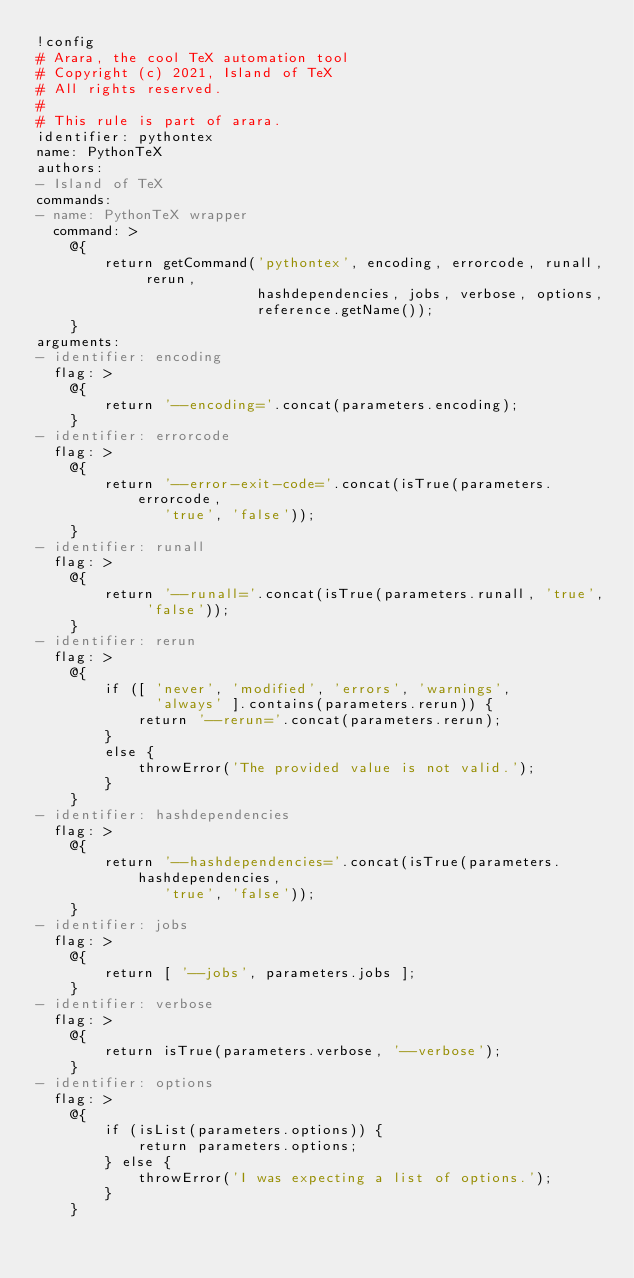Convert code to text. <code><loc_0><loc_0><loc_500><loc_500><_YAML_>!config
# Arara, the cool TeX automation tool
# Copyright (c) 2021, Island of TeX
# All rights reserved.
#
# This rule is part of arara.
identifier: pythontex
name: PythonTeX
authors:
- Island of TeX
commands:
- name: PythonTeX wrapper
  command: >
    @{
        return getCommand('pythontex', encoding, errorcode, runall, rerun,
                          hashdependencies, jobs, verbose, options,
                          reference.getName());
    }
arguments:
- identifier: encoding
  flag: >
    @{
        return '--encoding='.concat(parameters.encoding);
    }
- identifier: errorcode
  flag: >
    @{
        return '--error-exit-code='.concat(isTrue(parameters.errorcode,
               'true', 'false'));
    }
- identifier: runall
  flag: >
    @{
        return '--runall='.concat(isTrue(parameters.runall, 'true', 'false'));
    }
- identifier: rerun
  flag: >
    @{
        if ([ 'never', 'modified', 'errors', 'warnings',
              'always' ].contains(parameters.rerun)) {
            return '--rerun='.concat(parameters.rerun);
        }
        else {
            throwError('The provided value is not valid.');
        }
    }
- identifier: hashdependencies
  flag: >
    @{
        return '--hashdependencies='.concat(isTrue(parameters.hashdependencies,
               'true', 'false'));
    }
- identifier: jobs
  flag: >
    @{
        return [ '--jobs', parameters.jobs ];
    }
- identifier: verbose
  flag: >
    @{
        return isTrue(parameters.verbose, '--verbose');
    }
- identifier: options
  flag: >
    @{
        if (isList(parameters.options)) {
            return parameters.options;
        } else {
            throwError('I was expecting a list of options.');
        }
    }
</code> 